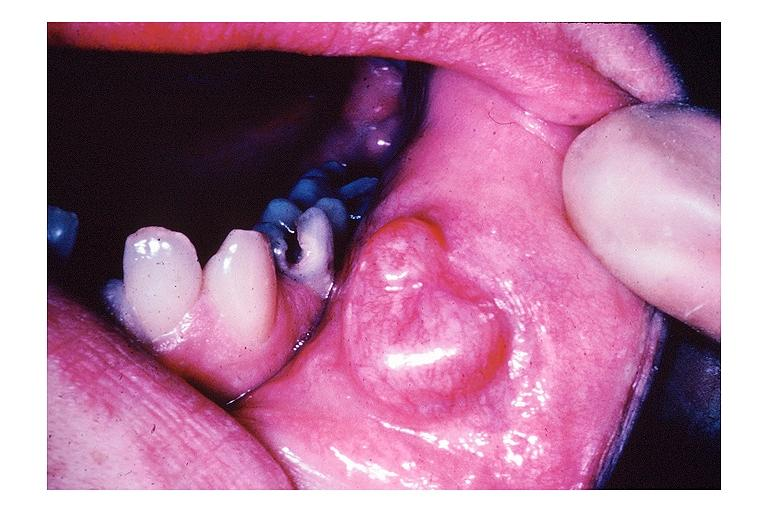s neurofibrillary change present?
Answer the question using a single word or phrase. No 